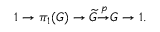<formula> <loc_0><loc_0><loc_500><loc_500>1 \to \pi _ { 1 } ( G ) \to { \widetilde { G } } { \overset { p } { \to } } G \to 1 .</formula> 